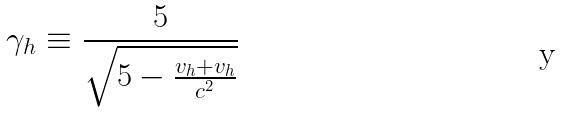<formula> <loc_0><loc_0><loc_500><loc_500>\gamma _ { h } \equiv \frac { 5 } { \sqrt { 5 - \frac { v _ { h } + v _ { h } } { c ^ { 2 } } } }</formula> 